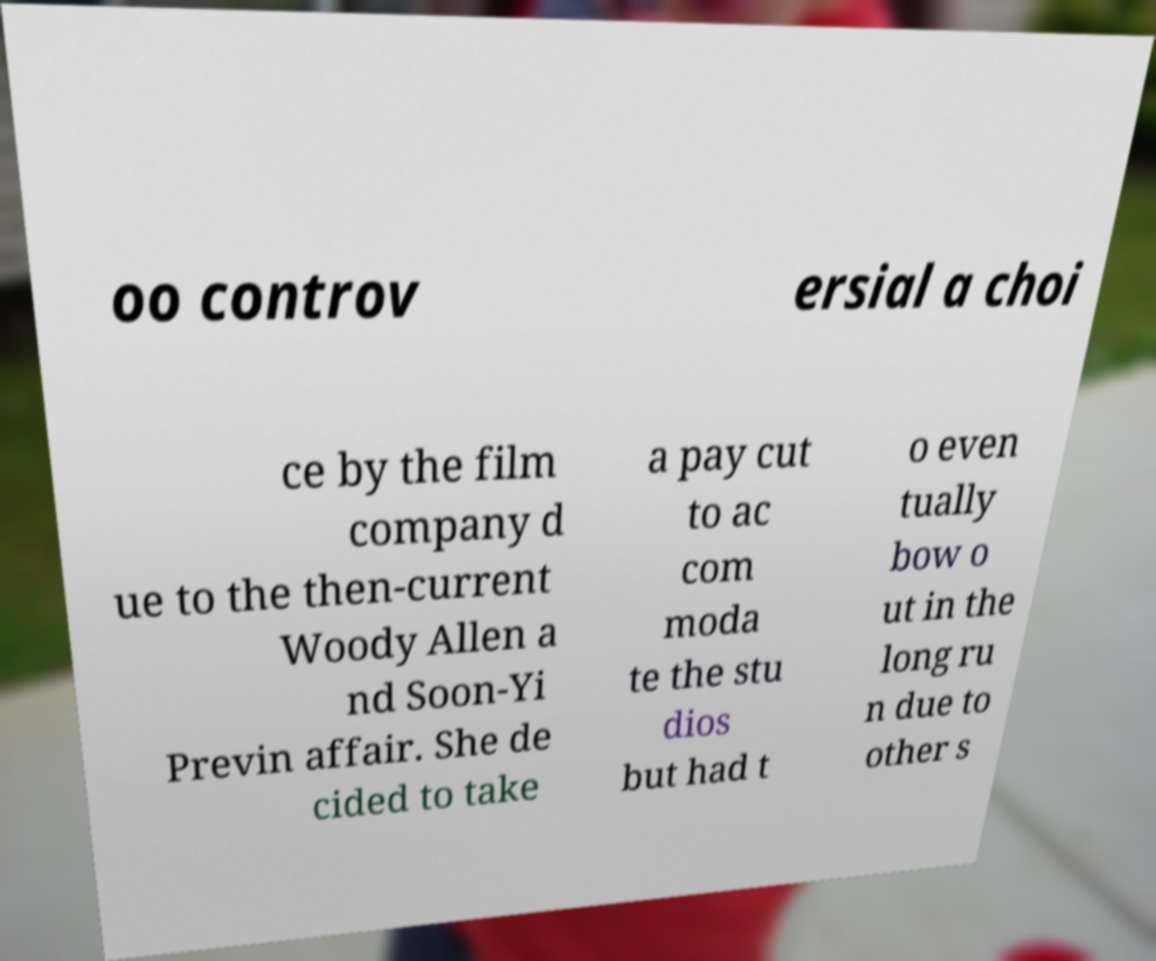Could you extract and type out the text from this image? oo controv ersial a choi ce by the film company d ue to the then-current Woody Allen a nd Soon-Yi Previn affair. She de cided to take a pay cut to ac com moda te the stu dios but had t o even tually bow o ut in the long ru n due to other s 